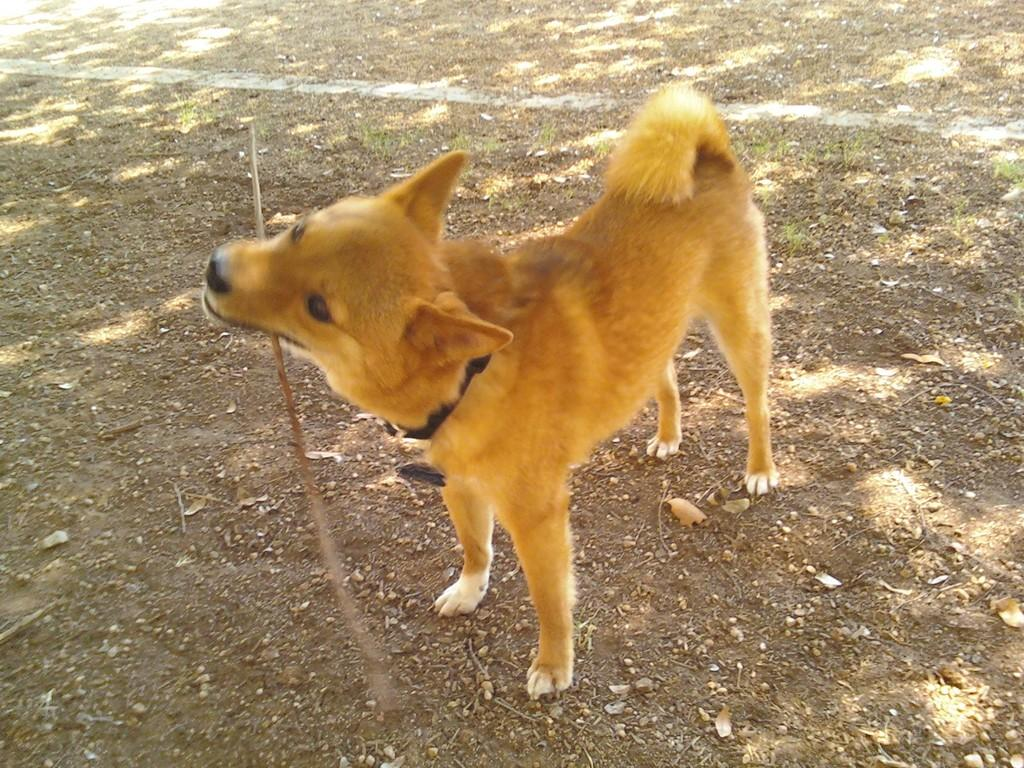What animal is present in the image? There is a dog in the image. Where is the dog located? The dog is on the ground. What is the dog doing with its mouth? The dog is holding a stick in its mouth. What type of texture can be seen on the chair in the image? There is no chair present in the image, so it is not possible to determine the texture of any chair. 